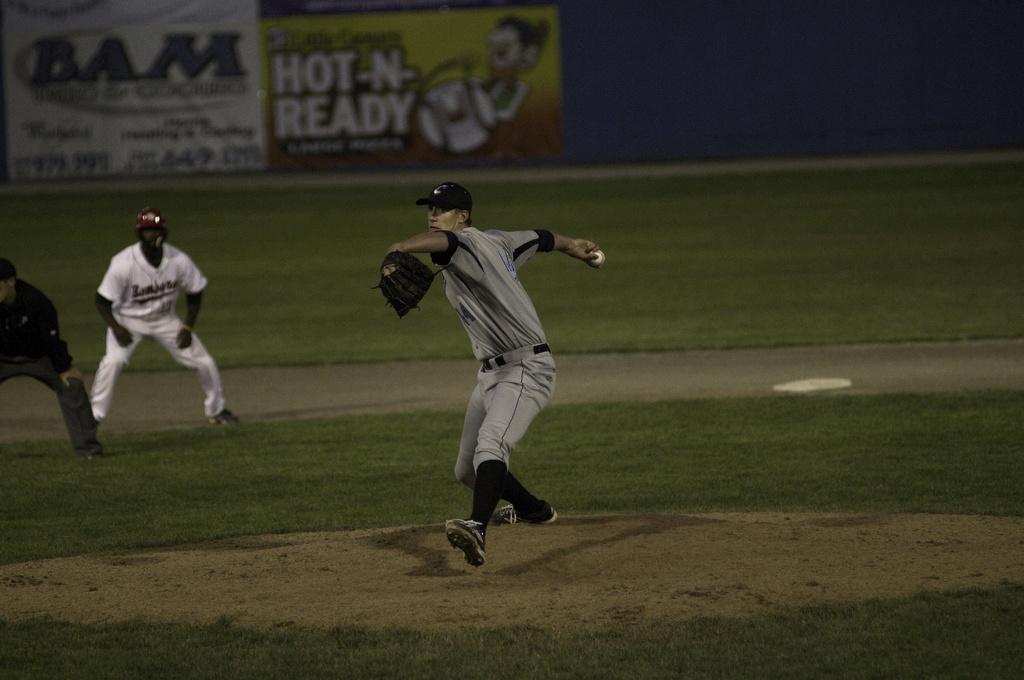Describe this image in one or two sentences. In this image there is a person throwing the ball. Beside him there are two other people standing on the grass. In the background of the image there is a banner. 